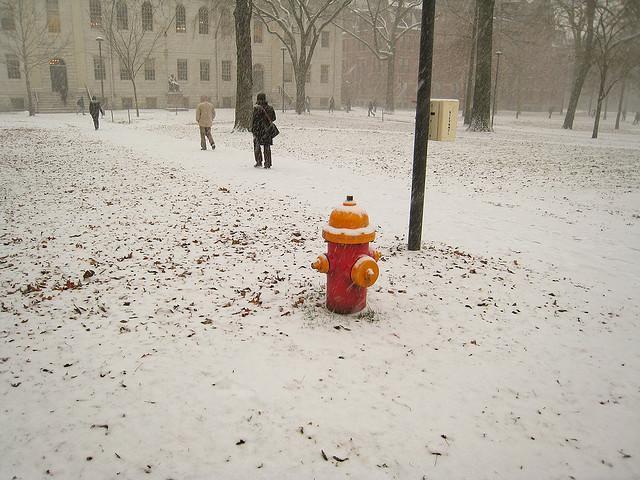How many train cars?
Give a very brief answer. 0. 